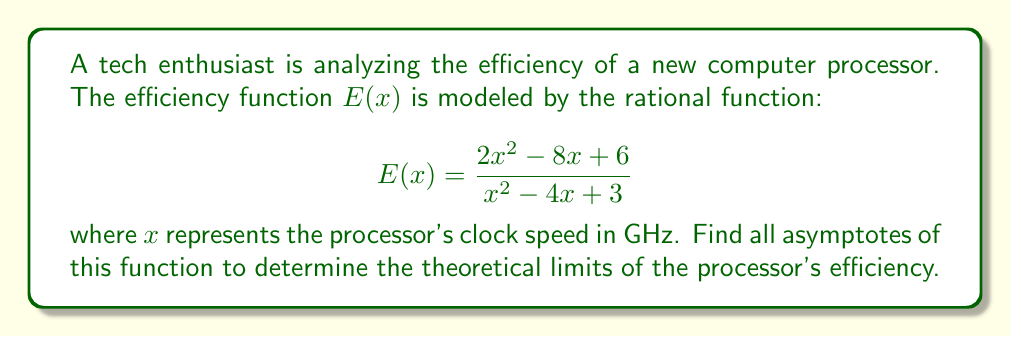Could you help me with this problem? To find the asymptotes, we'll follow these steps:

1) Vertical asymptotes:
   Set the denominator to zero and solve for x:
   $$x^2 - 4x + 3 = 0$$
   $$(x - 1)(x - 3) = 0$$
   $$x = 1 \text{ or } x = 3$$

2) Horizontal asymptote:
   Compare the degrees of the numerator and denominator:
   - Numerator degree: 2
   - Denominator degree: 2
   Since they're equal, the horizontal asymptote is the ratio of their leading coefficients:
   $$y = \frac{2}{1} = 2$$

3) Slant asymptote:
   Since the degree of the numerator equals the degree of the denominator, there is no slant asymptote.

4) To verify the horizontal asymptote, we can use the limit as x approaches infinity:
   $$\lim_{x \to \infty} \frac{2x^2 - 8x + 6}{x^2 - 4x + 3} = \lim_{x \to \infty} \frac{2 - \frac{8}{x} + \frac{6}{x^2}}{1 - \frac{4}{x} + \frac{3}{x^2}} = 2$$

Therefore, the asymptotes are:
- Vertical asymptotes: $x = 1$ and $x = 3$
- Horizontal asymptote: $y = 2$
Answer: Vertical: $x = 1$, $x = 3$; Horizontal: $y = 2$ 